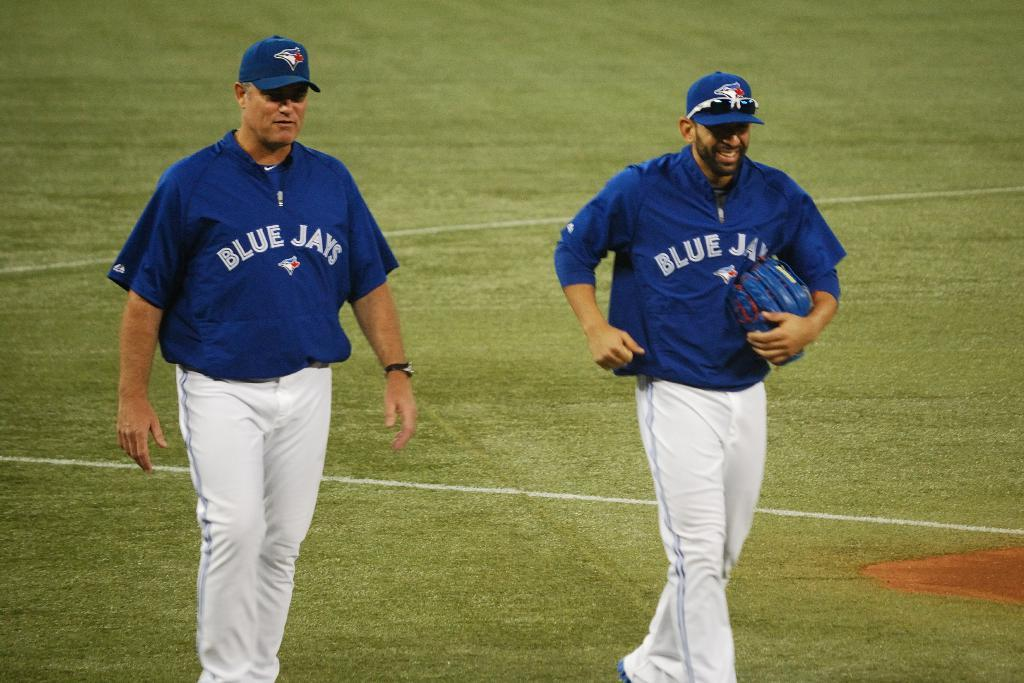Provide a one-sentence caption for the provided image. The men are dressed to play baseball for the Blue Jays. 